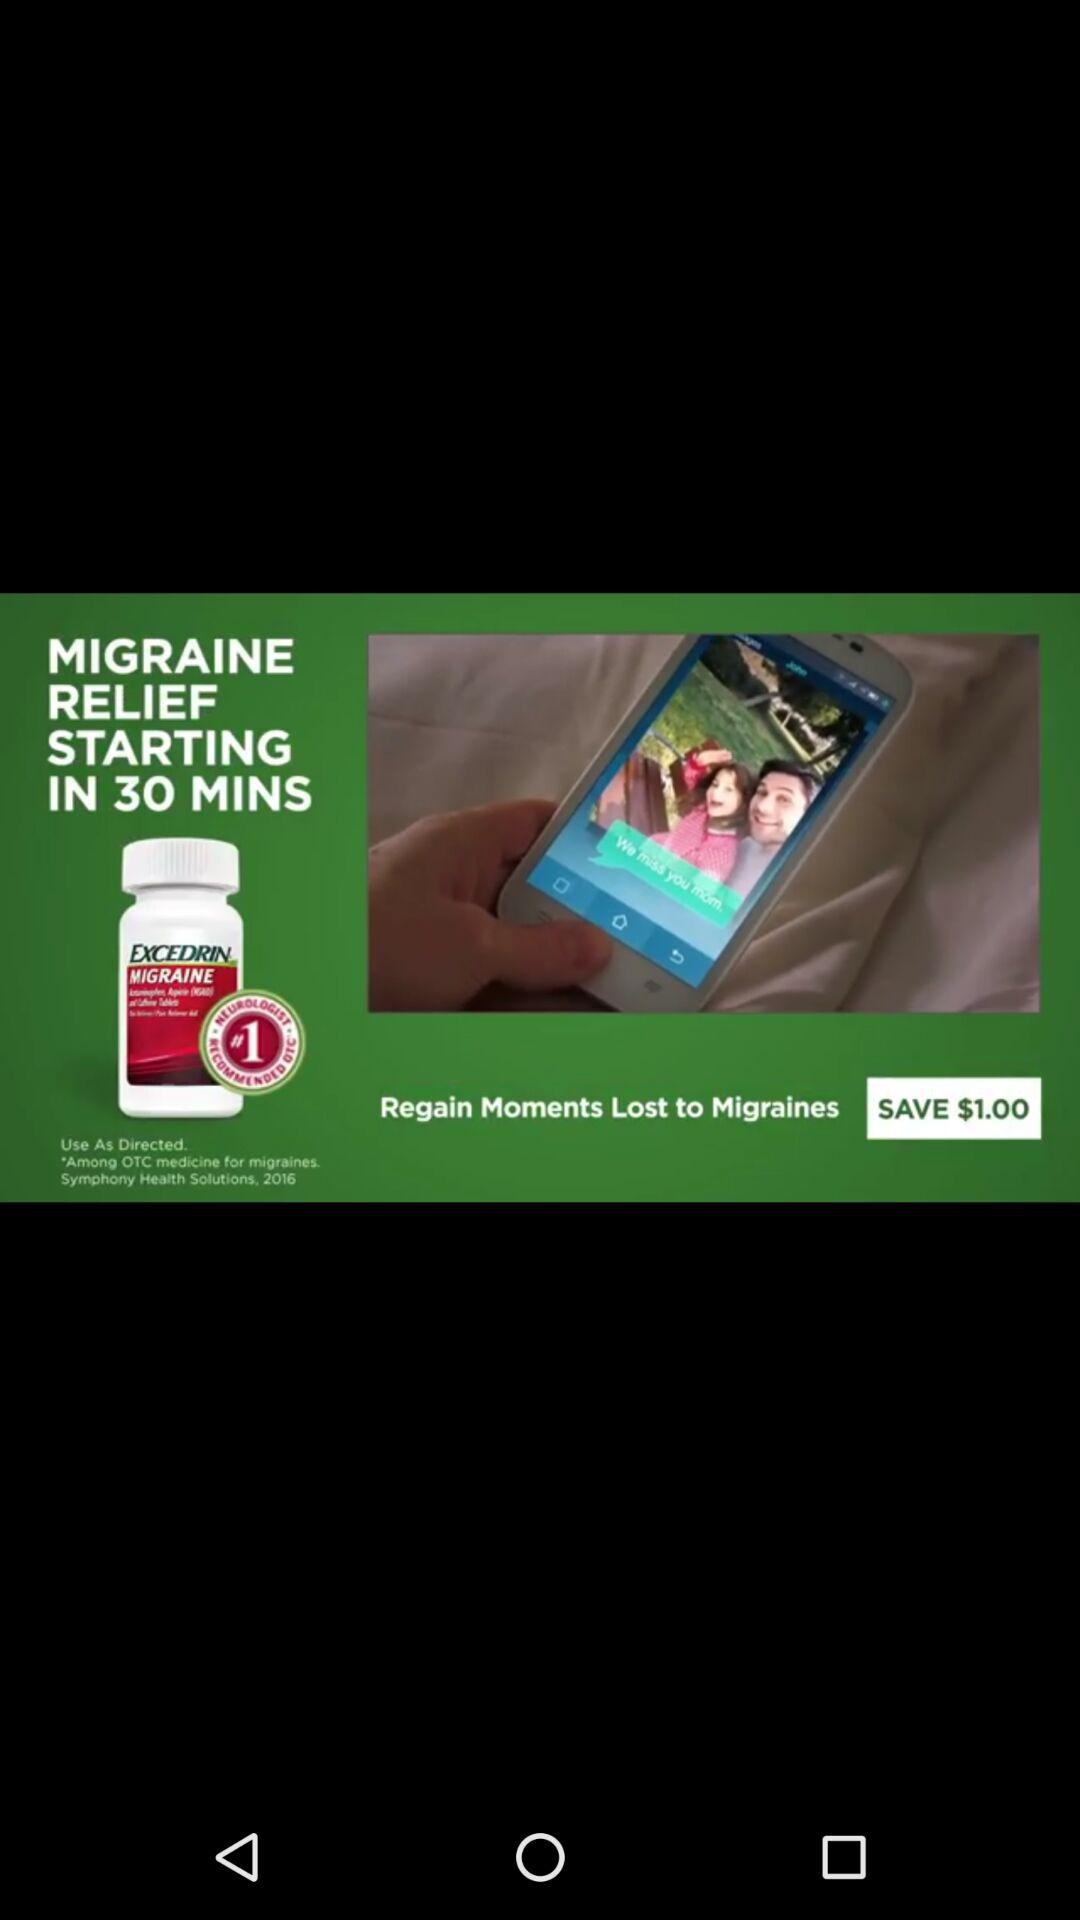How long will it take for relief to begin? The relief will begin in 30 minutes. 